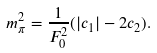Convert formula to latex. <formula><loc_0><loc_0><loc_500><loc_500>m _ { \pi } ^ { 2 } = \frac { 1 } { F _ { 0 } ^ { 2 } } ( | c _ { 1 } | - 2 c _ { 2 } ) .</formula> 